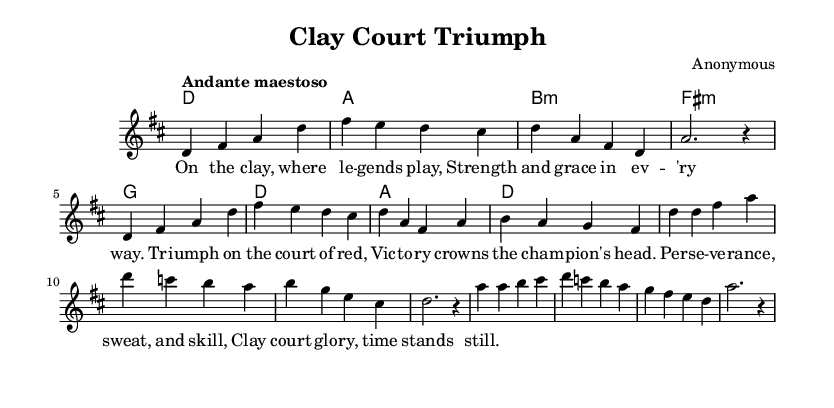What is the key signature of this music? The key signature is D major, which contains two sharps (F# and C#). This can be determined by looking at the key indicated at the beginning of the score.
Answer: D major What is the time signature of this piece? The time signature is 4/4, which means there are four beats in each measure. This is indicated at the beginning of the score right after the key signature.
Answer: 4/4 What is the tempo marking for this music? The tempo marking is "Andante maestoso," suggesting a moderate pace with a majestic feel. This can be found at the beginning of the score next to the time signature.
Answer: Andante maestoso How many measures are in the melody section? There are 12 measures in the melody section, counted from the beginning to the end of the provided melody. This includes measures from both the introduction and verses.
Answer: 12 What themes are celebrated in the lyrics of this aria? The lyrics celebrate themes of athletic achievement and perseverance, focusing on triumph, strength, and glory on the clay court. This can be inferred from analyzing the text provided in the lyric mode and its connection to the subject of fitness and triumph.
Answer: Athletic achievement and perseverance What is the harmonic structure used in the score? The harmonic structure consists of the chords D, A, B minor, F# minor, G, and D, which provide the foundation for the melody. This can be identified in the chord mode section, where the chords are laid out sequentially.
Answer: D, A, B minor, F# minor, G, D 